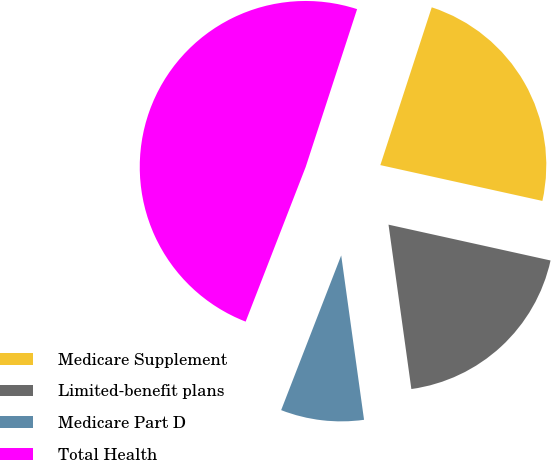<chart> <loc_0><loc_0><loc_500><loc_500><pie_chart><fcel>Medicare Supplement<fcel>Limited-benefit plans<fcel>Medicare Part D<fcel>Total Health<nl><fcel>23.45%<fcel>19.34%<fcel>8.09%<fcel>49.12%<nl></chart> 